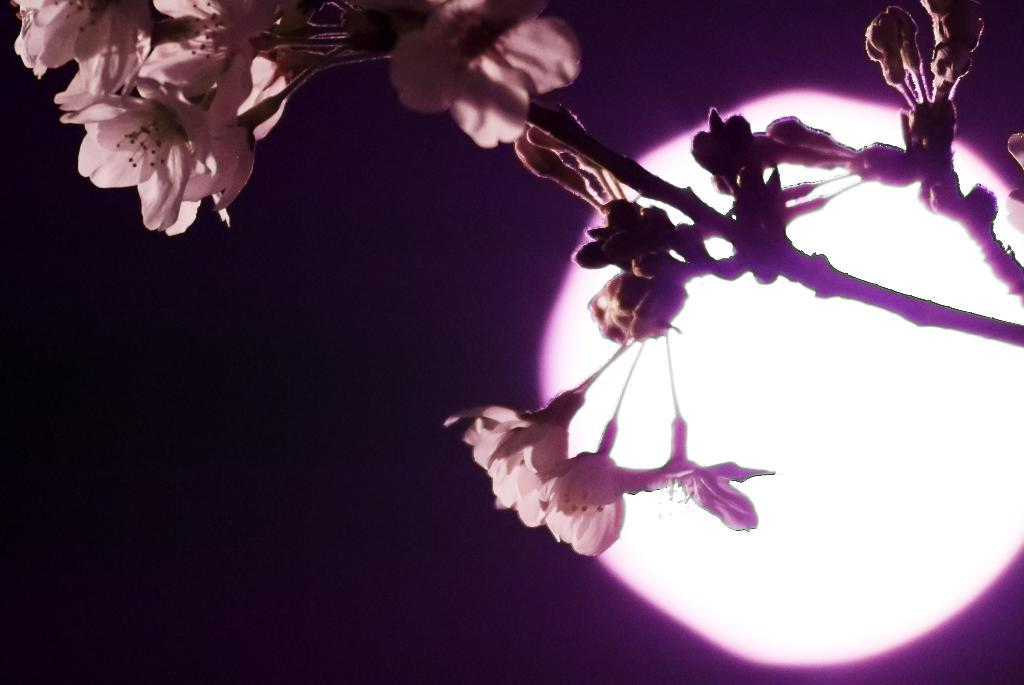What color is the cloth that is visible in the image? There is a violet color cloth in the image. What other objects can be seen in the image besides the cloth? There are flowers in the image. Can you describe the flowers in more detail? The flowers have stems. What is visible in the background of the image? The sky is visible in the image. What type of bead is used to decorate the trousers in the image? There are no trousers or beads present in the image. How does the sleet affect the visibility of the flowers in the image? There is no sleet present in the image, so it does not affect the visibility of the flowers. 